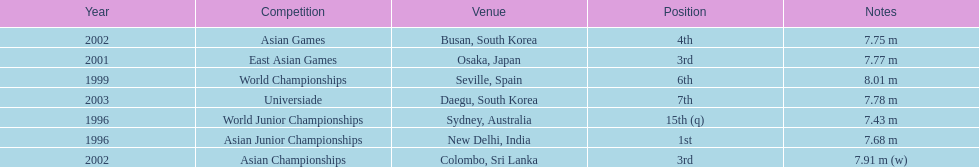What is the number of competitions that have been competed in? 7. 